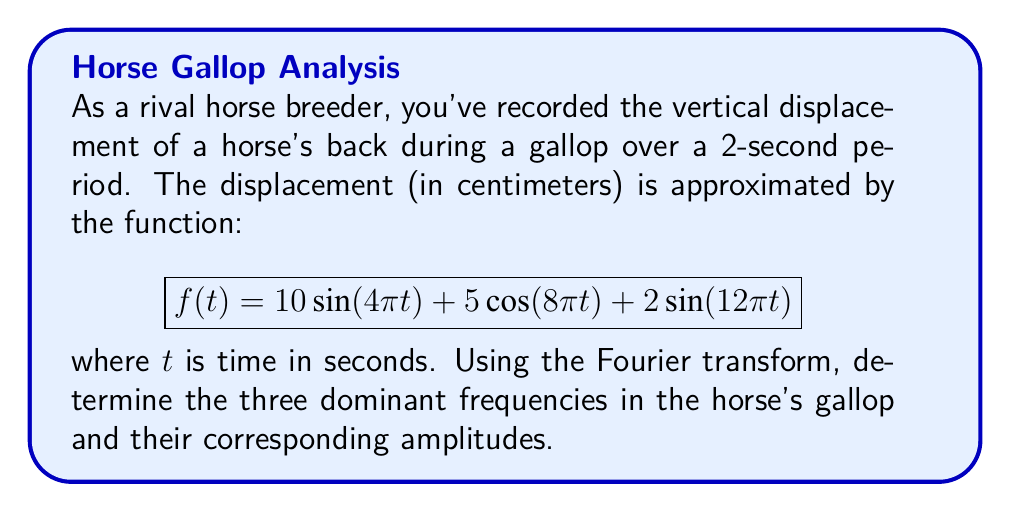Show me your answer to this math problem. To analyze the frequency spectrum of the horse's gallop, we'll use the Fourier transform. The given function is already expressed as a sum of sinusoids, which makes our task easier.

Step 1: Identify the general form of a Fourier series
A Fourier series can be written as:
$$f(t) = \sum_{n=1}^{\infty} A_n \sin(2\pi n f_0 t) + B_n \cos(2\pi n f_0 t)$$
where $f_0$ is the fundamental frequency, and $A_n$ and $B_n$ are the amplitudes.

Step 2: Compare our function to the general form
$$f(t) = 10\sin(4\pi t) + 5\cos(8\pi t) + 2\sin(12\pi t)$$

Step 3: Identify the frequencies and amplitudes
- Term 1: $10\sin(4\pi t)$
  Frequency: $f_1 = 4\pi/(2\pi) = 2$ Hz
  Amplitude: $A_1 = 10$ cm

- Term 2: $5\cos(8\pi t)$
  Frequency: $f_2 = 8\pi/(2\pi) = 4$ Hz
  Amplitude: $B_2 = 5$ cm

- Term 3: $2\sin(12\pi t)$
  Frequency: $f_3 = 12\pi/(2\pi) = 6$ Hz
  Amplitude: $A_3 = 2$ cm

Step 4: Order the frequencies by amplitude
1. 2 Hz with amplitude 10 cm
2. 4 Hz with amplitude 5 cm
3. 6 Hz with amplitude 2 cm

These are the three dominant frequencies in the horse's gallop and their corresponding amplitudes.
Answer: 2 Hz (10 cm), 4 Hz (5 cm), 6 Hz (2 cm) 